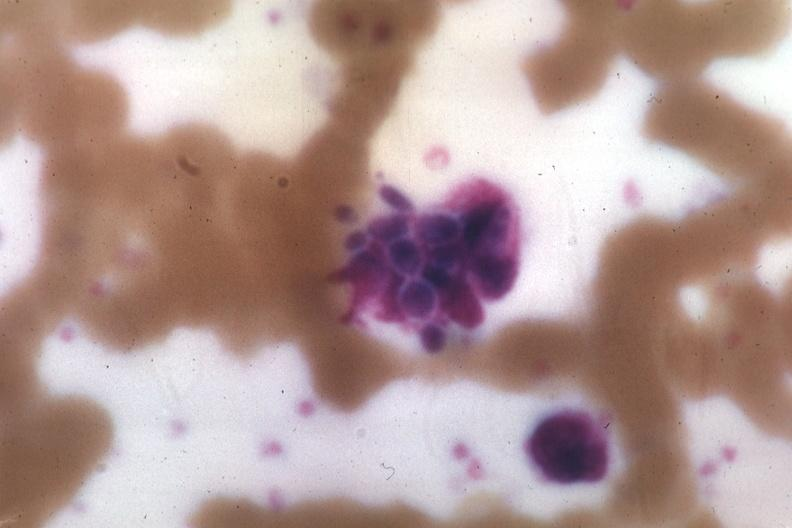s lymphangiomatosis generalized present?
Answer the question using a single word or phrase. No 